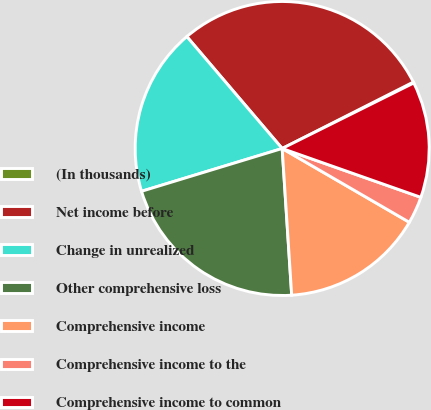Convert chart to OTSL. <chart><loc_0><loc_0><loc_500><loc_500><pie_chart><fcel>(In thousands)<fcel>Net income before<fcel>Change in unrealized<fcel>Other comprehensive loss<fcel>Comprehensive income<fcel>Comprehensive income to the<fcel>Comprehensive income to common<nl><fcel>0.11%<fcel>28.77%<fcel>18.47%<fcel>21.33%<fcel>15.6%<fcel>2.98%<fcel>12.74%<nl></chart> 